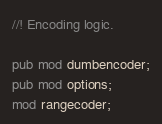<code> <loc_0><loc_0><loc_500><loc_500><_Rust_>//! Encoding logic.

pub mod dumbencoder;
pub mod options;
mod rangecoder;
</code> 